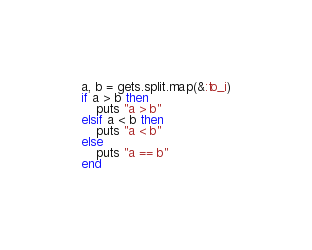Convert code to text. <code><loc_0><loc_0><loc_500><loc_500><_Ruby_>a, b = gets.split.map(&:to_i)
if a > b then
	puts "a > b"
elsif a < b then
	puts "a < b"
else
	puts "a == b"
end</code> 